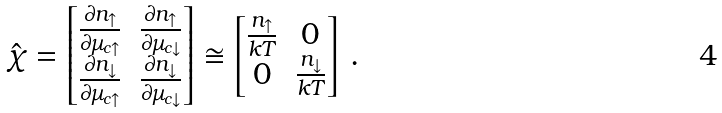Convert formula to latex. <formula><loc_0><loc_0><loc_500><loc_500>\hat { \chi } = \begin{bmatrix} \frac { \partial n _ { \uparrow } } { \partial \mu _ { c \uparrow } } & \frac { \partial n _ { \uparrow } } { \partial \mu _ { c \downarrow } } \\ \frac { \partial n _ { \downarrow } } { \partial \mu _ { c \uparrow } } & \frac { \partial n _ { \downarrow } } { \partial \mu _ { c \downarrow } } \end{bmatrix} \cong \begin{bmatrix} \frac { n _ { \uparrow } } { k T } & 0 \\ 0 & \frac { n _ { \downarrow } } { k T } \end{bmatrix} \, .</formula> 